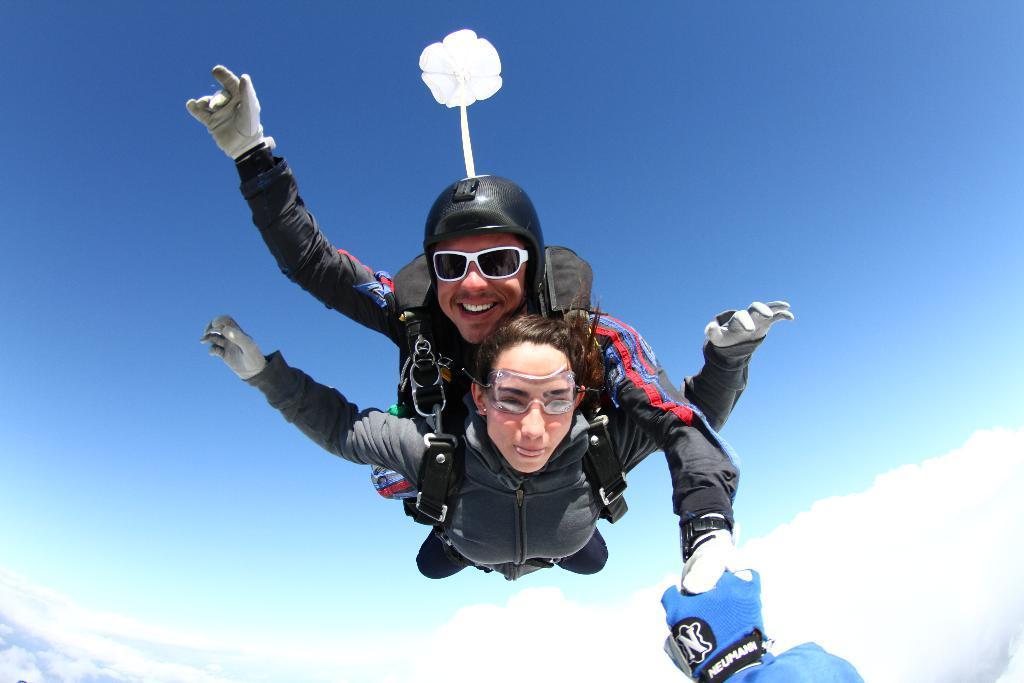How would you summarize this image in a sentence or two? In this image we can see a man and a woman doing skydiving. In the background we can see sky and clouds. 